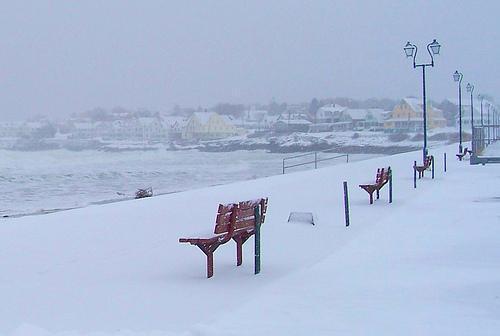How many legs does each bench have?
Give a very brief answer. 2. 